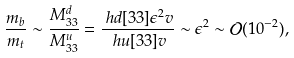<formula> <loc_0><loc_0><loc_500><loc_500>\frac { m _ { b } } { m _ { t } } \sim \frac { M ^ { d } _ { 3 3 } } { M ^ { u } _ { 3 3 } } & = \frac { \ h d [ 3 3 ] \epsilon ^ { 2 } v } { \ h u [ 3 3 ] v } \sim \epsilon ^ { 2 } \sim \mathcal { O } ( 1 0 ^ { - 2 } ) ,</formula> 